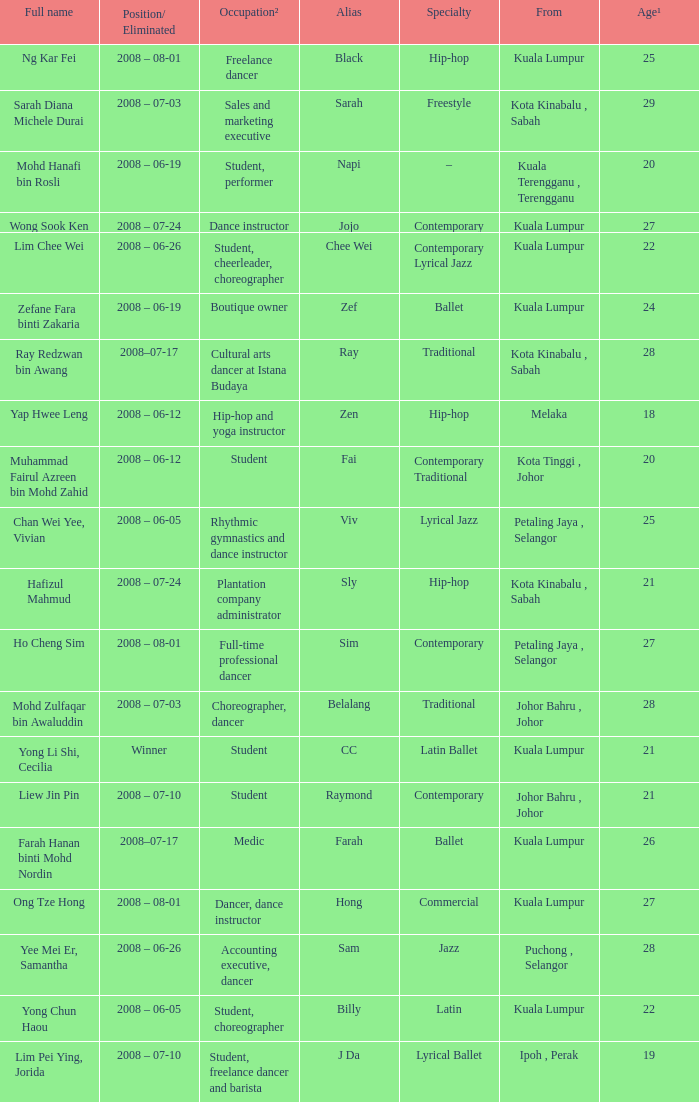What is Occupation², when Age¹ is greater than 24, when Alias is "Black"? Freelance dancer. 